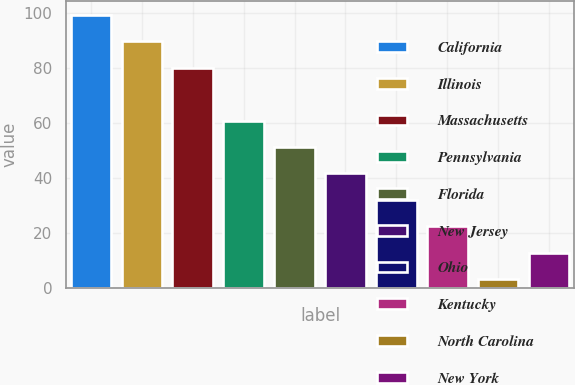Convert chart. <chart><loc_0><loc_0><loc_500><loc_500><bar_chart><fcel>California<fcel>Illinois<fcel>Massachusetts<fcel>Pennsylvania<fcel>Florida<fcel>New Jersey<fcel>Ohio<fcel>Kentucky<fcel>North Carolina<fcel>New York<nl><fcel>99.3<fcel>89.69<fcel>80.08<fcel>60.86<fcel>51.25<fcel>41.64<fcel>32.03<fcel>22.42<fcel>3.2<fcel>12.81<nl></chart> 